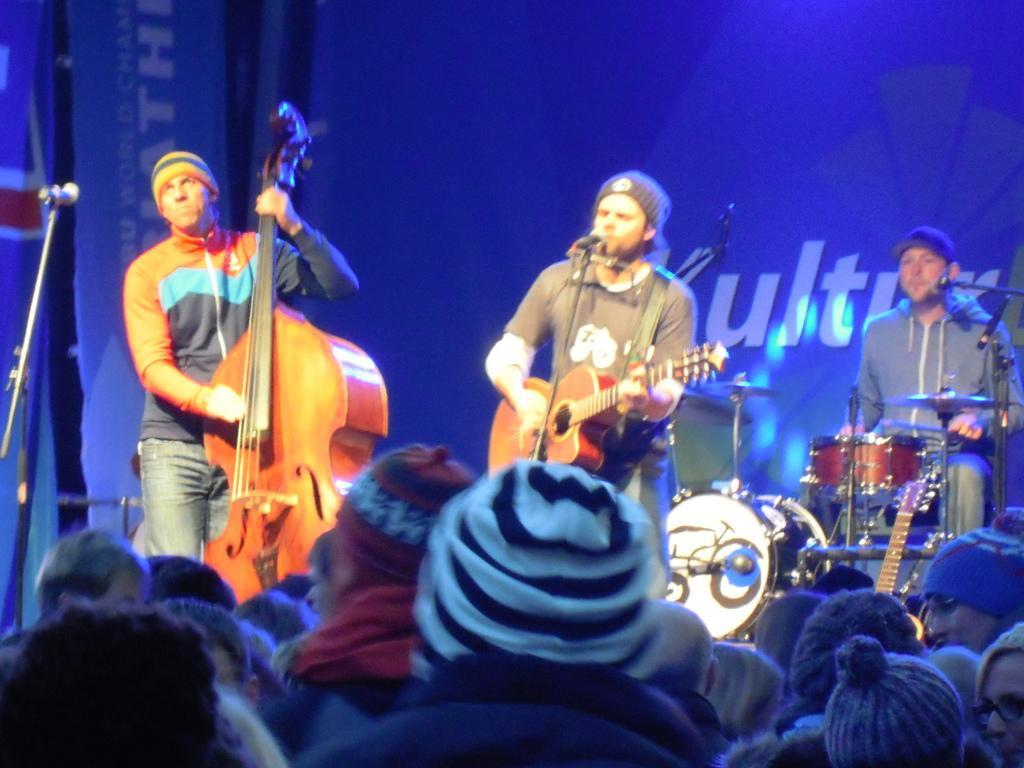In one or two sentences, can you explain what this image depicts? In the image we can see there are people who are sitting and they are watching the people who are standing and they are playing musical instruments. 